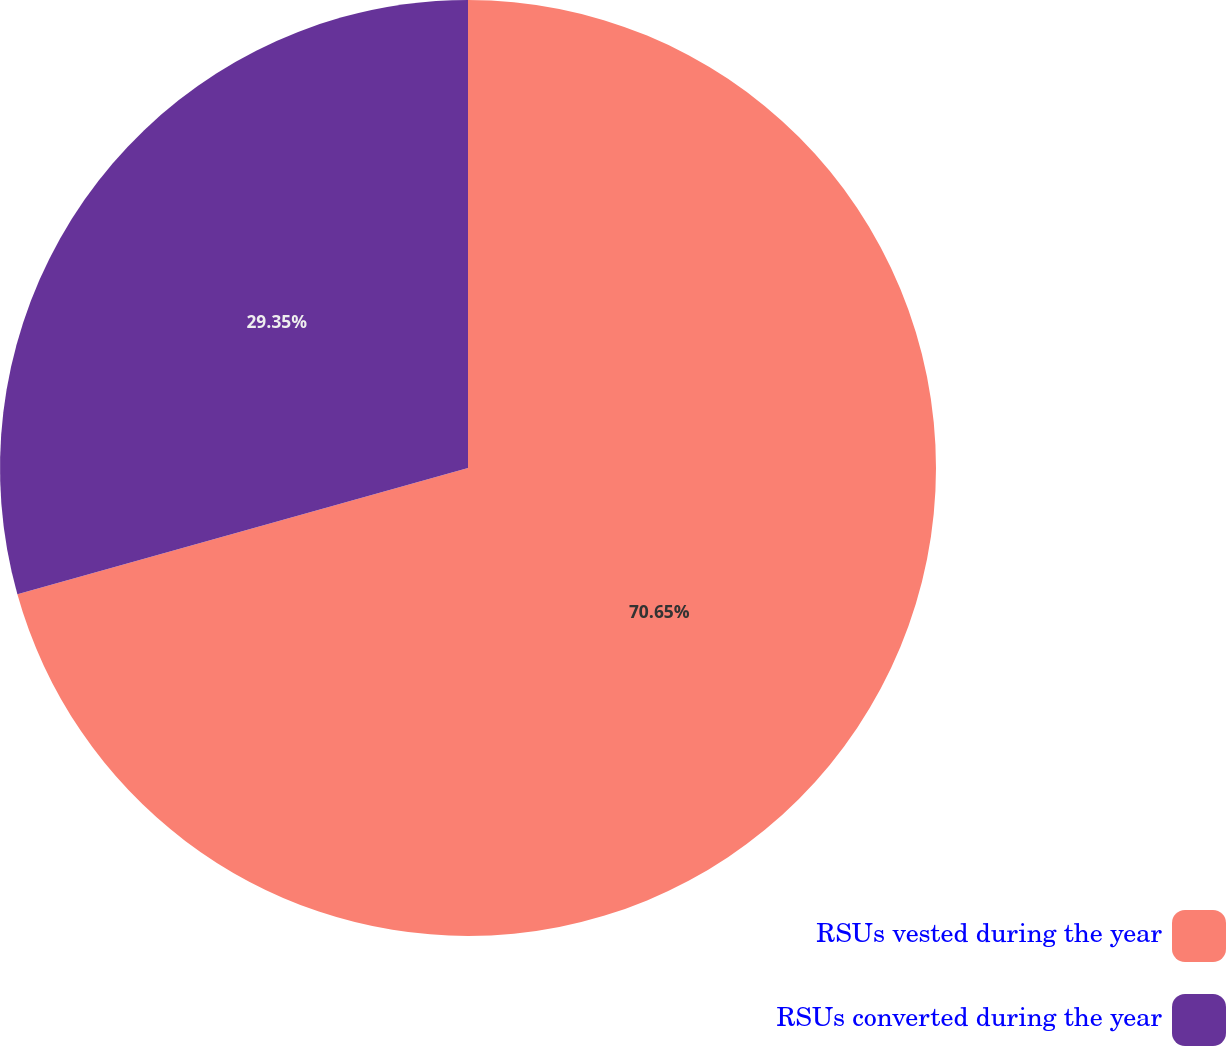<chart> <loc_0><loc_0><loc_500><loc_500><pie_chart><fcel>RSUs vested during the year<fcel>RSUs converted during the year<nl><fcel>70.65%<fcel>29.35%<nl></chart> 